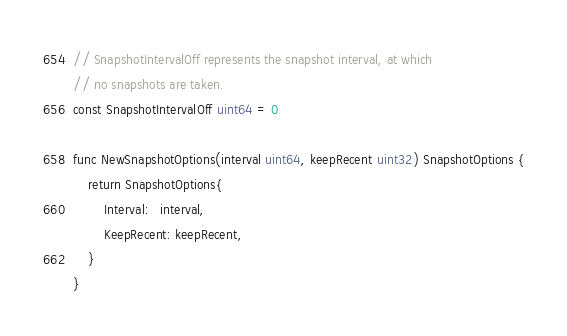<code> <loc_0><loc_0><loc_500><loc_500><_Go_>// SnapshotIntervalOff represents the snapshot interval, at which
// no snapshots are taken.
const SnapshotIntervalOff uint64 = 0

func NewSnapshotOptions(interval uint64, keepRecent uint32) SnapshotOptions {
	return SnapshotOptions{
		Interval:   interval,
		KeepRecent: keepRecent,
	}
}
</code> 